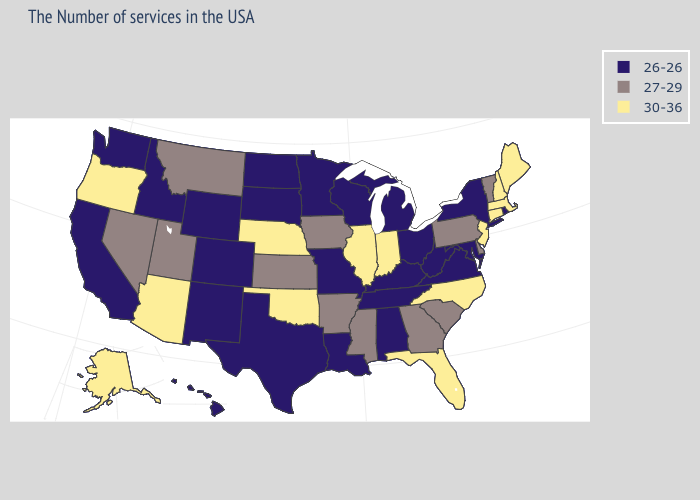Does the first symbol in the legend represent the smallest category?
Concise answer only. Yes. What is the value of Georgia?
Write a very short answer. 27-29. What is the highest value in the West ?
Write a very short answer. 30-36. Name the states that have a value in the range 30-36?
Quick response, please. Maine, Massachusetts, New Hampshire, Connecticut, New Jersey, North Carolina, Florida, Indiana, Illinois, Nebraska, Oklahoma, Arizona, Oregon, Alaska. What is the value of Oklahoma?
Write a very short answer. 30-36. How many symbols are there in the legend?
Answer briefly. 3. Among the states that border Illinois , which have the lowest value?
Give a very brief answer. Kentucky, Wisconsin, Missouri. Among the states that border Maine , which have the lowest value?
Be succinct. New Hampshire. Which states hav the highest value in the West?
Answer briefly. Arizona, Oregon, Alaska. What is the value of Kansas?
Concise answer only. 27-29. Name the states that have a value in the range 30-36?
Write a very short answer. Maine, Massachusetts, New Hampshire, Connecticut, New Jersey, North Carolina, Florida, Indiana, Illinois, Nebraska, Oklahoma, Arizona, Oregon, Alaska. Is the legend a continuous bar?
Give a very brief answer. No. Does the first symbol in the legend represent the smallest category?
Write a very short answer. Yes. Which states have the lowest value in the West?
Write a very short answer. Wyoming, Colorado, New Mexico, Idaho, California, Washington, Hawaii. Among the states that border California , which have the highest value?
Keep it brief. Arizona, Oregon. 